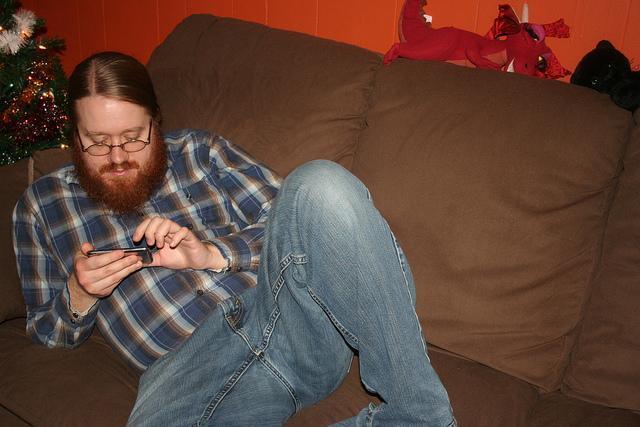Is this affirmation: "The couch is surrounding the person." correct?
Answer yes or no. No. 